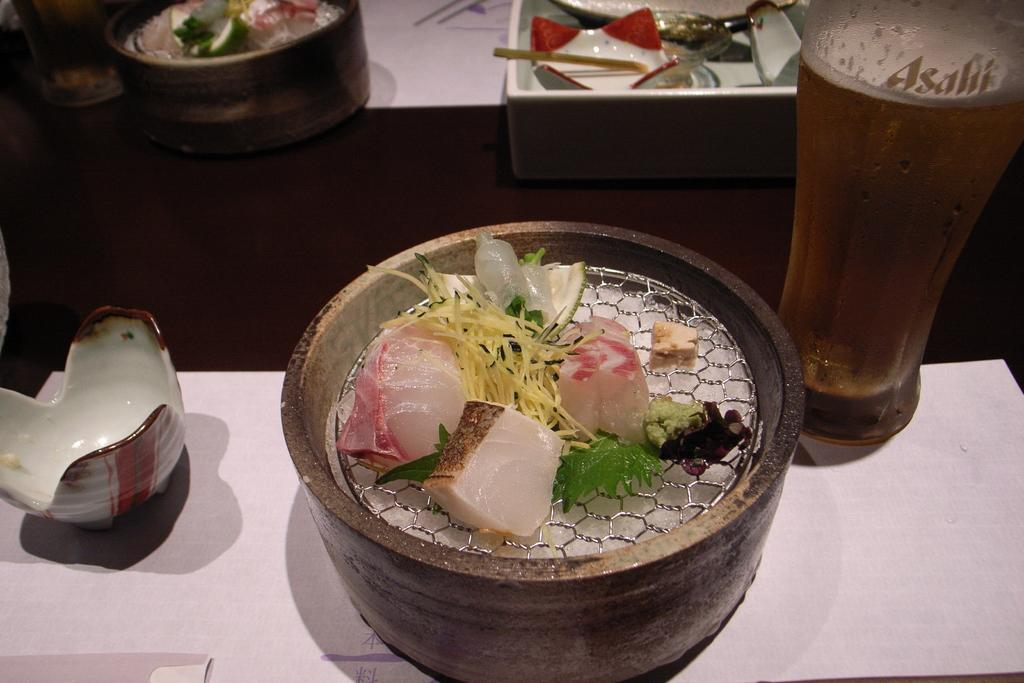What is in the bowl that is visible in the image? The bowl contains meat. What beverage is visible in the image? There is a glass of beer on the right side of the image. What other items can be seen in the background of the image? There are bowls and trays in the background of the image. What type of establishment might the image be depicting? The setting appears to be a restaurant. What type of powder can be seen covering the meat in the image? There is no powder visible on the meat in the image; it appears to be plain meat in a bowl. 